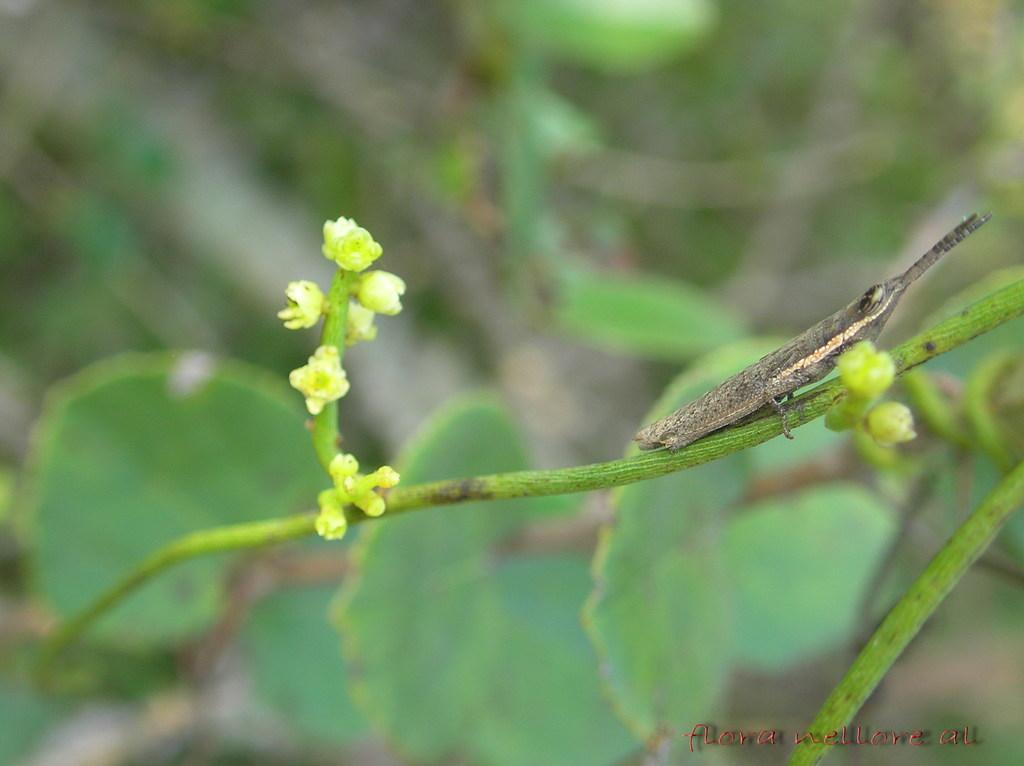What type of creature can be seen in the image? There is an insect in the image. Where is the insect located? The insect is on a plant. How much money is the insect holding in the image? There is no money present in the image, and insects do not hold money. 